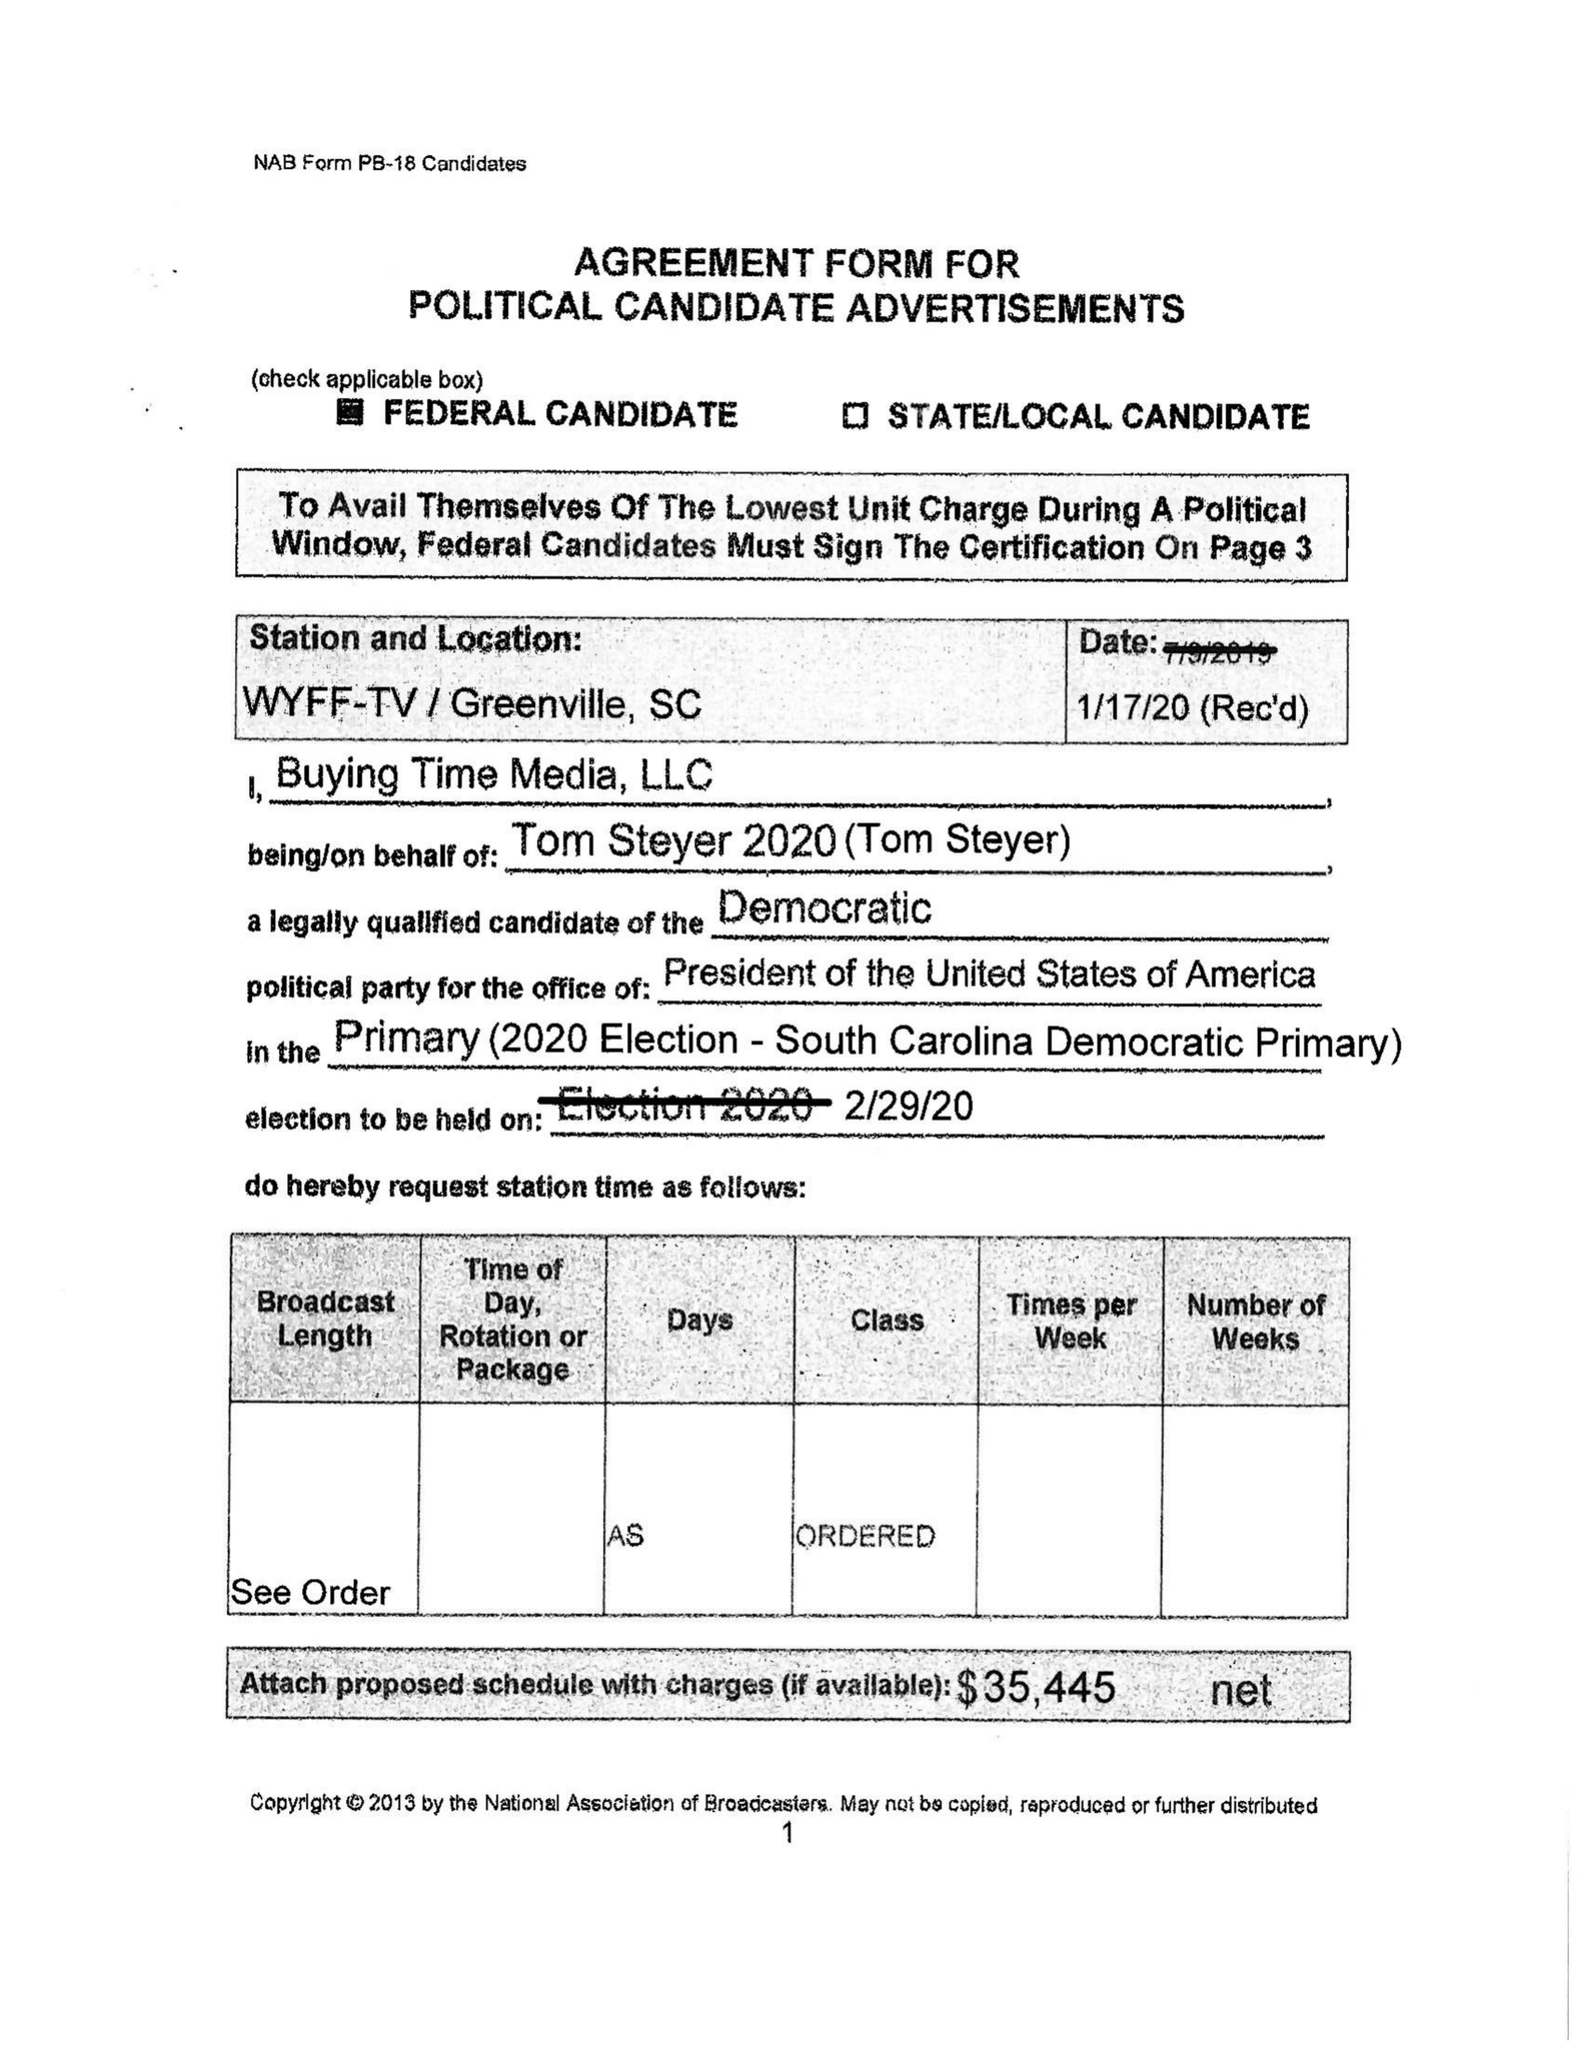What is the value for the flight_from?
Answer the question using a single word or phrase. None 